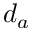Convert formula to latex. <formula><loc_0><loc_0><loc_500><loc_500>d _ { a }</formula> 